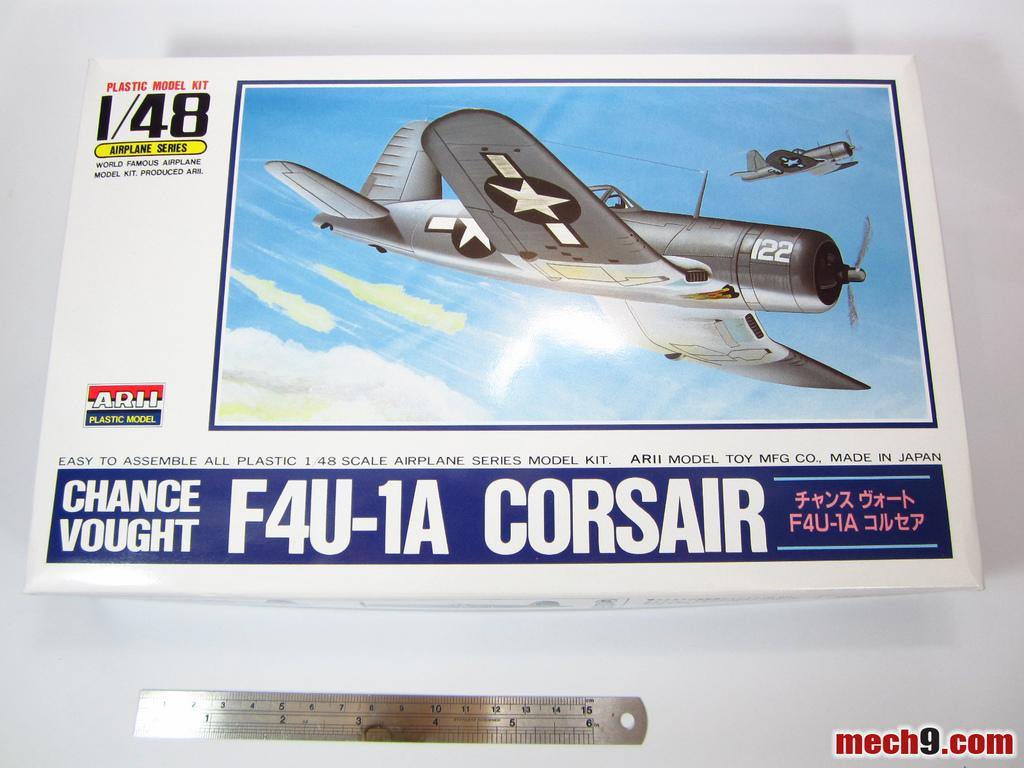<image>
Write a terse but informative summary of the picture. A plastic airplane kit of Corsair is on the table along with a ruler. 